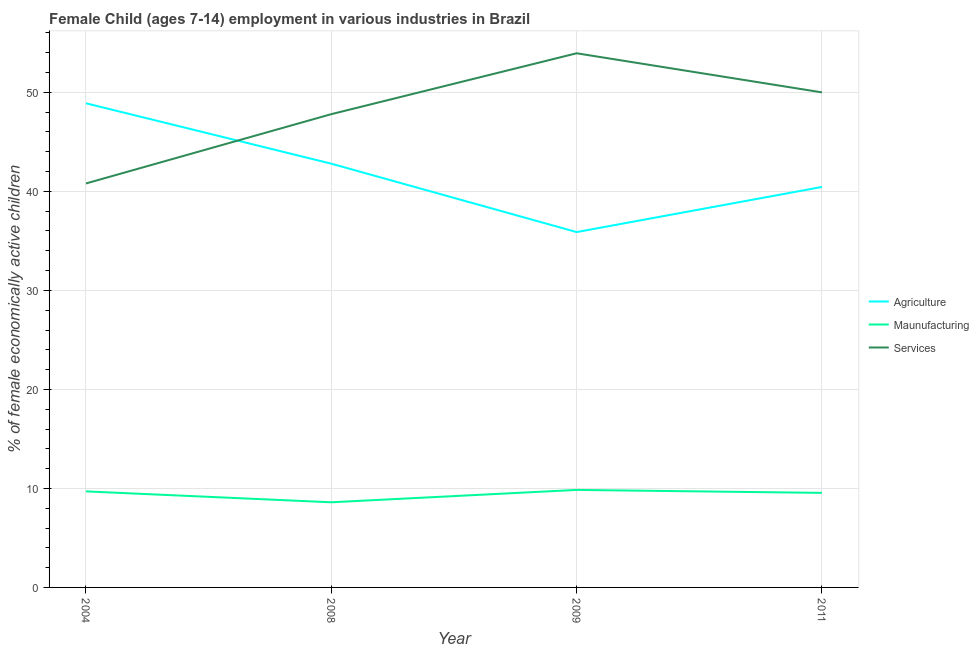How many different coloured lines are there?
Your response must be concise. 3. Does the line corresponding to percentage of economically active children in services intersect with the line corresponding to percentage of economically active children in manufacturing?
Provide a succinct answer. No. Is the number of lines equal to the number of legend labels?
Make the answer very short. Yes. What is the percentage of economically active children in manufacturing in 2009?
Offer a terse response. 9.85. Across all years, what is the maximum percentage of economically active children in manufacturing?
Offer a terse response. 9.85. What is the total percentage of economically active children in manufacturing in the graph?
Provide a short and direct response. 37.7. What is the difference between the percentage of economically active children in manufacturing in 2008 and that in 2011?
Provide a short and direct response. -0.95. What is the difference between the percentage of economically active children in agriculture in 2011 and the percentage of economically active children in services in 2004?
Provide a short and direct response. -0.35. What is the average percentage of economically active children in agriculture per year?
Give a very brief answer. 42.01. In the year 2008, what is the difference between the percentage of economically active children in services and percentage of economically active children in manufacturing?
Keep it short and to the point. 39.2. In how many years, is the percentage of economically active children in services greater than 26 %?
Make the answer very short. 4. What is the ratio of the percentage of economically active children in services in 2004 to that in 2011?
Ensure brevity in your answer.  0.82. Is the percentage of economically active children in manufacturing in 2004 less than that in 2009?
Offer a terse response. Yes. What is the difference between the highest and the second highest percentage of economically active children in services?
Your response must be concise. 3.95. Is the sum of the percentage of economically active children in agriculture in 2004 and 2009 greater than the maximum percentage of economically active children in services across all years?
Give a very brief answer. Yes. Does the percentage of economically active children in agriculture monotonically increase over the years?
Offer a very short reply. No. Is the percentage of economically active children in agriculture strictly greater than the percentage of economically active children in manufacturing over the years?
Keep it short and to the point. Yes. Is the percentage of economically active children in services strictly less than the percentage of economically active children in agriculture over the years?
Make the answer very short. No. What is the difference between two consecutive major ticks on the Y-axis?
Offer a terse response. 10. Does the graph contain grids?
Make the answer very short. Yes. What is the title of the graph?
Provide a short and direct response. Female Child (ages 7-14) employment in various industries in Brazil. Does "Wage workers" appear as one of the legend labels in the graph?
Give a very brief answer. No. What is the label or title of the Y-axis?
Your answer should be compact. % of female economically active children. What is the % of female economically active children of Agriculture in 2004?
Your response must be concise. 48.9. What is the % of female economically active children in Services in 2004?
Your answer should be compact. 40.8. What is the % of female economically active children of Agriculture in 2008?
Give a very brief answer. 42.8. What is the % of female economically active children in Maunufacturing in 2008?
Give a very brief answer. 8.6. What is the % of female economically active children in Services in 2008?
Keep it short and to the point. 47.8. What is the % of female economically active children in Agriculture in 2009?
Provide a succinct answer. 35.89. What is the % of female economically active children in Maunufacturing in 2009?
Make the answer very short. 9.85. What is the % of female economically active children in Services in 2009?
Make the answer very short. 53.95. What is the % of female economically active children of Agriculture in 2011?
Offer a very short reply. 40.45. What is the % of female economically active children in Maunufacturing in 2011?
Ensure brevity in your answer.  9.55. What is the % of female economically active children in Services in 2011?
Provide a short and direct response. 50. Across all years, what is the maximum % of female economically active children in Agriculture?
Your answer should be compact. 48.9. Across all years, what is the maximum % of female economically active children in Maunufacturing?
Your response must be concise. 9.85. Across all years, what is the maximum % of female economically active children in Services?
Provide a succinct answer. 53.95. Across all years, what is the minimum % of female economically active children of Agriculture?
Make the answer very short. 35.89. Across all years, what is the minimum % of female economically active children in Maunufacturing?
Provide a succinct answer. 8.6. Across all years, what is the minimum % of female economically active children of Services?
Keep it short and to the point. 40.8. What is the total % of female economically active children in Agriculture in the graph?
Ensure brevity in your answer.  168.04. What is the total % of female economically active children in Maunufacturing in the graph?
Provide a short and direct response. 37.7. What is the total % of female economically active children in Services in the graph?
Offer a terse response. 192.55. What is the difference between the % of female economically active children in Agriculture in 2004 and that in 2008?
Provide a short and direct response. 6.1. What is the difference between the % of female economically active children of Maunufacturing in 2004 and that in 2008?
Make the answer very short. 1.1. What is the difference between the % of female economically active children in Agriculture in 2004 and that in 2009?
Give a very brief answer. 13.01. What is the difference between the % of female economically active children of Maunufacturing in 2004 and that in 2009?
Your answer should be very brief. -0.15. What is the difference between the % of female economically active children of Services in 2004 and that in 2009?
Offer a terse response. -13.15. What is the difference between the % of female economically active children of Agriculture in 2004 and that in 2011?
Make the answer very short. 8.45. What is the difference between the % of female economically active children in Maunufacturing in 2004 and that in 2011?
Your answer should be very brief. 0.15. What is the difference between the % of female economically active children in Agriculture in 2008 and that in 2009?
Keep it short and to the point. 6.91. What is the difference between the % of female economically active children of Maunufacturing in 2008 and that in 2009?
Your answer should be very brief. -1.25. What is the difference between the % of female economically active children of Services in 2008 and that in 2009?
Your answer should be compact. -6.15. What is the difference between the % of female economically active children of Agriculture in 2008 and that in 2011?
Make the answer very short. 2.35. What is the difference between the % of female economically active children of Maunufacturing in 2008 and that in 2011?
Offer a terse response. -0.95. What is the difference between the % of female economically active children in Services in 2008 and that in 2011?
Make the answer very short. -2.2. What is the difference between the % of female economically active children in Agriculture in 2009 and that in 2011?
Offer a terse response. -4.56. What is the difference between the % of female economically active children of Services in 2009 and that in 2011?
Ensure brevity in your answer.  3.95. What is the difference between the % of female economically active children in Agriculture in 2004 and the % of female economically active children in Maunufacturing in 2008?
Offer a very short reply. 40.3. What is the difference between the % of female economically active children in Agriculture in 2004 and the % of female economically active children in Services in 2008?
Give a very brief answer. 1.1. What is the difference between the % of female economically active children of Maunufacturing in 2004 and the % of female economically active children of Services in 2008?
Your answer should be very brief. -38.1. What is the difference between the % of female economically active children in Agriculture in 2004 and the % of female economically active children in Maunufacturing in 2009?
Make the answer very short. 39.05. What is the difference between the % of female economically active children of Agriculture in 2004 and the % of female economically active children of Services in 2009?
Provide a succinct answer. -5.05. What is the difference between the % of female economically active children in Maunufacturing in 2004 and the % of female economically active children in Services in 2009?
Your answer should be very brief. -44.25. What is the difference between the % of female economically active children of Agriculture in 2004 and the % of female economically active children of Maunufacturing in 2011?
Your answer should be very brief. 39.35. What is the difference between the % of female economically active children of Maunufacturing in 2004 and the % of female economically active children of Services in 2011?
Provide a succinct answer. -40.3. What is the difference between the % of female economically active children of Agriculture in 2008 and the % of female economically active children of Maunufacturing in 2009?
Your answer should be compact. 32.95. What is the difference between the % of female economically active children in Agriculture in 2008 and the % of female economically active children in Services in 2009?
Provide a succinct answer. -11.15. What is the difference between the % of female economically active children in Maunufacturing in 2008 and the % of female economically active children in Services in 2009?
Keep it short and to the point. -45.35. What is the difference between the % of female economically active children in Agriculture in 2008 and the % of female economically active children in Maunufacturing in 2011?
Give a very brief answer. 33.25. What is the difference between the % of female economically active children in Maunufacturing in 2008 and the % of female economically active children in Services in 2011?
Provide a succinct answer. -41.4. What is the difference between the % of female economically active children of Agriculture in 2009 and the % of female economically active children of Maunufacturing in 2011?
Your response must be concise. 26.34. What is the difference between the % of female economically active children in Agriculture in 2009 and the % of female economically active children in Services in 2011?
Your answer should be compact. -14.11. What is the difference between the % of female economically active children in Maunufacturing in 2009 and the % of female economically active children in Services in 2011?
Keep it short and to the point. -40.15. What is the average % of female economically active children of Agriculture per year?
Keep it short and to the point. 42.01. What is the average % of female economically active children of Maunufacturing per year?
Give a very brief answer. 9.43. What is the average % of female economically active children of Services per year?
Provide a short and direct response. 48.14. In the year 2004, what is the difference between the % of female economically active children of Agriculture and % of female economically active children of Maunufacturing?
Your answer should be very brief. 39.2. In the year 2004, what is the difference between the % of female economically active children in Agriculture and % of female economically active children in Services?
Give a very brief answer. 8.1. In the year 2004, what is the difference between the % of female economically active children of Maunufacturing and % of female economically active children of Services?
Your answer should be compact. -31.1. In the year 2008, what is the difference between the % of female economically active children in Agriculture and % of female economically active children in Maunufacturing?
Ensure brevity in your answer.  34.2. In the year 2008, what is the difference between the % of female economically active children of Maunufacturing and % of female economically active children of Services?
Your answer should be compact. -39.2. In the year 2009, what is the difference between the % of female economically active children of Agriculture and % of female economically active children of Maunufacturing?
Your answer should be very brief. 26.04. In the year 2009, what is the difference between the % of female economically active children in Agriculture and % of female economically active children in Services?
Your answer should be compact. -18.06. In the year 2009, what is the difference between the % of female economically active children in Maunufacturing and % of female economically active children in Services?
Give a very brief answer. -44.1. In the year 2011, what is the difference between the % of female economically active children in Agriculture and % of female economically active children in Maunufacturing?
Offer a very short reply. 30.9. In the year 2011, what is the difference between the % of female economically active children in Agriculture and % of female economically active children in Services?
Ensure brevity in your answer.  -9.55. In the year 2011, what is the difference between the % of female economically active children in Maunufacturing and % of female economically active children in Services?
Your answer should be very brief. -40.45. What is the ratio of the % of female economically active children of Agriculture in 2004 to that in 2008?
Your answer should be very brief. 1.14. What is the ratio of the % of female economically active children of Maunufacturing in 2004 to that in 2008?
Provide a short and direct response. 1.13. What is the ratio of the % of female economically active children in Services in 2004 to that in 2008?
Your answer should be very brief. 0.85. What is the ratio of the % of female economically active children in Agriculture in 2004 to that in 2009?
Your answer should be very brief. 1.36. What is the ratio of the % of female economically active children in Services in 2004 to that in 2009?
Offer a very short reply. 0.76. What is the ratio of the % of female economically active children in Agriculture in 2004 to that in 2011?
Make the answer very short. 1.21. What is the ratio of the % of female economically active children in Maunufacturing in 2004 to that in 2011?
Your answer should be compact. 1.02. What is the ratio of the % of female economically active children in Services in 2004 to that in 2011?
Your answer should be very brief. 0.82. What is the ratio of the % of female economically active children in Agriculture in 2008 to that in 2009?
Your answer should be very brief. 1.19. What is the ratio of the % of female economically active children of Maunufacturing in 2008 to that in 2009?
Offer a terse response. 0.87. What is the ratio of the % of female economically active children in Services in 2008 to that in 2009?
Provide a succinct answer. 0.89. What is the ratio of the % of female economically active children of Agriculture in 2008 to that in 2011?
Your answer should be very brief. 1.06. What is the ratio of the % of female economically active children of Maunufacturing in 2008 to that in 2011?
Make the answer very short. 0.9. What is the ratio of the % of female economically active children of Services in 2008 to that in 2011?
Give a very brief answer. 0.96. What is the ratio of the % of female economically active children of Agriculture in 2009 to that in 2011?
Offer a very short reply. 0.89. What is the ratio of the % of female economically active children of Maunufacturing in 2009 to that in 2011?
Your answer should be very brief. 1.03. What is the ratio of the % of female economically active children of Services in 2009 to that in 2011?
Your answer should be very brief. 1.08. What is the difference between the highest and the second highest % of female economically active children of Agriculture?
Your response must be concise. 6.1. What is the difference between the highest and the second highest % of female economically active children in Maunufacturing?
Your answer should be compact. 0.15. What is the difference between the highest and the second highest % of female economically active children in Services?
Provide a succinct answer. 3.95. What is the difference between the highest and the lowest % of female economically active children of Agriculture?
Your answer should be compact. 13.01. What is the difference between the highest and the lowest % of female economically active children of Maunufacturing?
Offer a very short reply. 1.25. What is the difference between the highest and the lowest % of female economically active children of Services?
Ensure brevity in your answer.  13.15. 